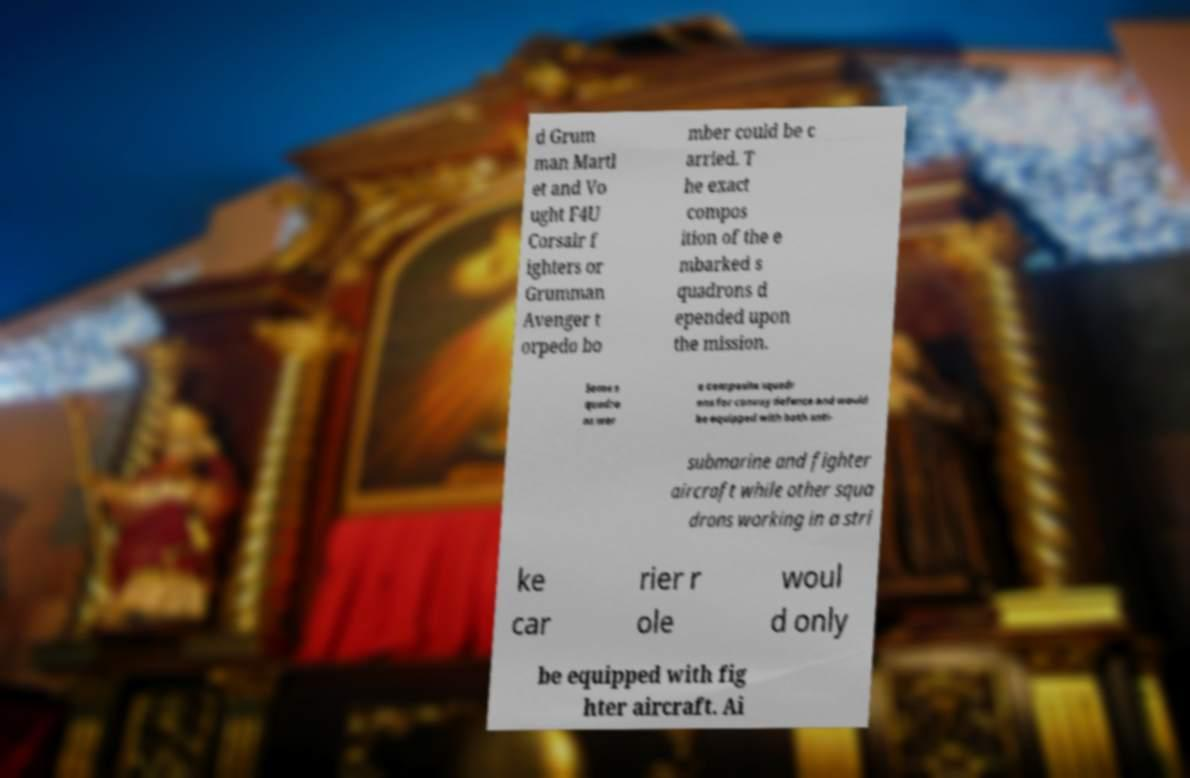What messages or text are displayed in this image? I need them in a readable, typed format. d Grum man Martl et and Vo ught F4U Corsair f ighters or Grumman Avenger t orpedo bo mber could be c arried. T he exact compos ition of the e mbarked s quadrons d epended upon the mission. Some s quadro ns wer e composite squadr ons for convoy defence and would be equipped with both anti- submarine and fighter aircraft while other squa drons working in a stri ke car rier r ole woul d only be equipped with fig hter aircraft. Ai 